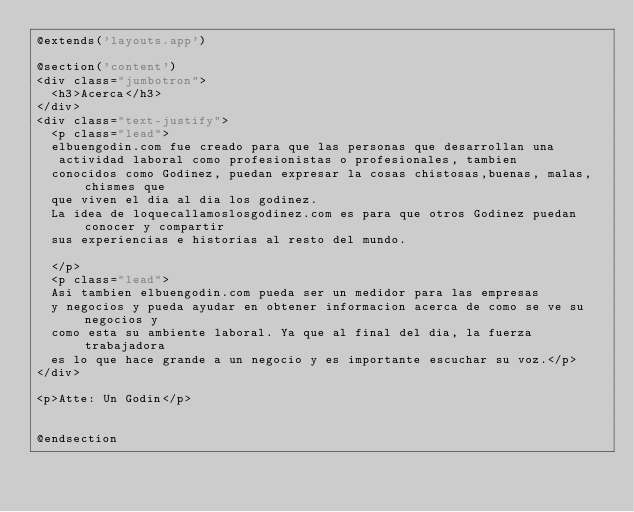<code> <loc_0><loc_0><loc_500><loc_500><_PHP_>@extends('layouts.app')

@section('content')
<div class="jumbotron">
  <h3>Acerca</h3>
</div>
<div class="text-justify">
  <p class="lead">
  elbuengodin.com fue creado para que las personas que desarrollan una
   actividad laboral como profesionistas o profesionales, tambien
  conocidos como Godinez, puedan expresar la cosas chistosas,buenas, malas, chismes que
  que viven el dia al dia los godinez.
  La idea de loquecallamoslosgodinez.com es para que otros Godinez puedan conocer y compartir
  sus experiencias e historias al resto del mundo.

  </p>
  <p class="lead">
  Asi tambien elbuengodin.com pueda ser un medidor para las empresas
  y negocios y pueda ayudar en obtener informacion acerca de como se ve su negocios y
  como esta su ambiente laboral. Ya que al final del dia, la fuerza trabajadora
  es lo que hace grande a un negocio y es importante escuchar su voz.</p>
</div>

<p>Atte: Un Godin</p>


@endsection
</code> 